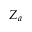<formula> <loc_0><loc_0><loc_500><loc_500>Z _ { a }</formula> 